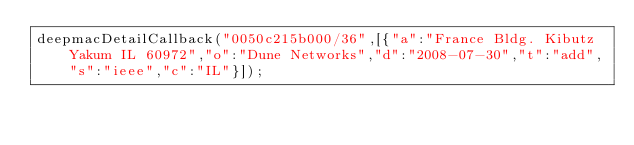<code> <loc_0><loc_0><loc_500><loc_500><_JavaScript_>deepmacDetailCallback("0050c215b000/36",[{"a":"France Bldg. Kibutz Yakum IL 60972","o":"Dune Networks","d":"2008-07-30","t":"add","s":"ieee","c":"IL"}]);
</code> 